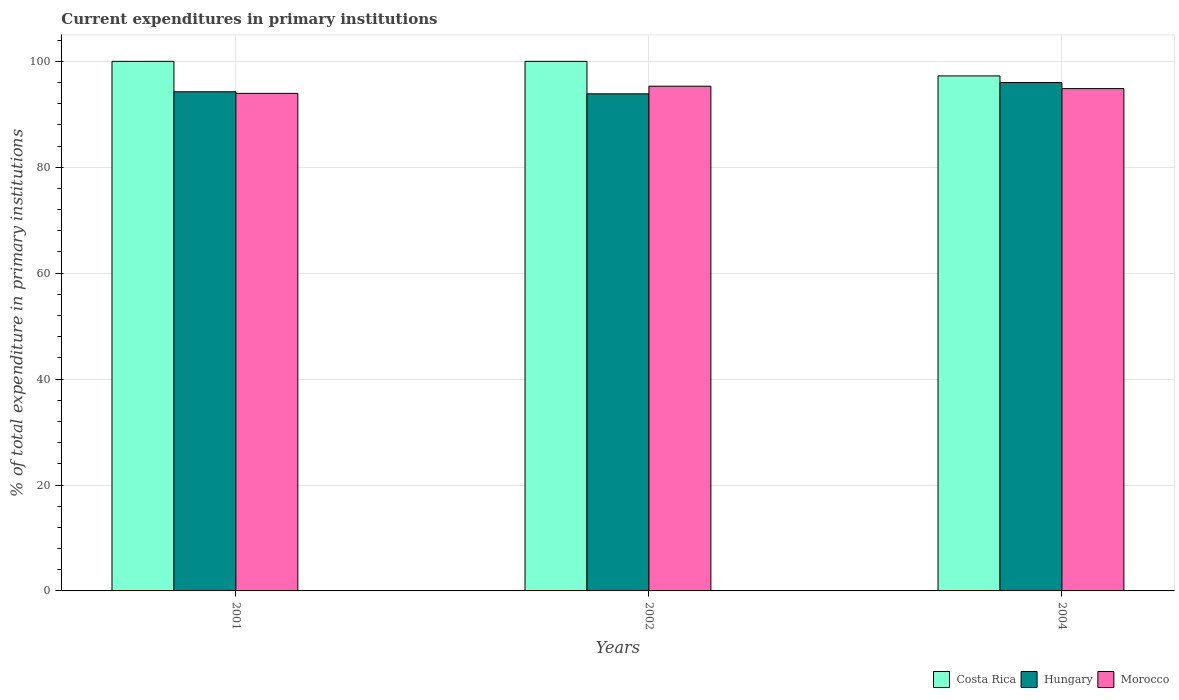How many bars are there on the 3rd tick from the left?
Your answer should be compact. 3. How many bars are there on the 1st tick from the right?
Offer a very short reply. 3. What is the label of the 2nd group of bars from the left?
Provide a short and direct response. 2002. Across all years, what is the maximum current expenditures in primary institutions in Morocco?
Ensure brevity in your answer.  95.31. Across all years, what is the minimum current expenditures in primary institutions in Hungary?
Keep it short and to the point. 93.87. In which year was the current expenditures in primary institutions in Morocco maximum?
Your response must be concise. 2002. What is the total current expenditures in primary institutions in Costa Rica in the graph?
Offer a very short reply. 297.25. What is the difference between the current expenditures in primary institutions in Morocco in 2001 and that in 2004?
Provide a short and direct response. -0.9. What is the difference between the current expenditures in primary institutions in Hungary in 2001 and the current expenditures in primary institutions in Costa Rica in 2004?
Your response must be concise. -2.99. What is the average current expenditures in primary institutions in Hungary per year?
Offer a terse response. 94.71. In the year 2001, what is the difference between the current expenditures in primary institutions in Morocco and current expenditures in primary institutions in Hungary?
Your answer should be very brief. -0.3. What is the ratio of the current expenditures in primary institutions in Morocco in 2002 to that in 2004?
Provide a short and direct response. 1. Is the current expenditures in primary institutions in Costa Rica in 2001 less than that in 2002?
Offer a terse response. No. What is the difference between the highest and the second highest current expenditures in primary institutions in Morocco?
Your response must be concise. 0.46. What is the difference between the highest and the lowest current expenditures in primary institutions in Morocco?
Your answer should be compact. 1.36. Is the sum of the current expenditures in primary institutions in Morocco in 2002 and 2004 greater than the maximum current expenditures in primary institutions in Costa Rica across all years?
Make the answer very short. Yes. What does the 2nd bar from the right in 2001 represents?
Your response must be concise. Hungary. Is it the case that in every year, the sum of the current expenditures in primary institutions in Costa Rica and current expenditures in primary institutions in Hungary is greater than the current expenditures in primary institutions in Morocco?
Offer a terse response. Yes. What is the difference between two consecutive major ticks on the Y-axis?
Keep it short and to the point. 20. Are the values on the major ticks of Y-axis written in scientific E-notation?
Provide a succinct answer. No. Where does the legend appear in the graph?
Your answer should be compact. Bottom right. How are the legend labels stacked?
Offer a terse response. Horizontal. What is the title of the graph?
Offer a very short reply. Current expenditures in primary institutions. Does "Belgium" appear as one of the legend labels in the graph?
Your answer should be compact. No. What is the label or title of the Y-axis?
Ensure brevity in your answer.  % of total expenditure in primary institutions. What is the % of total expenditure in primary institutions of Costa Rica in 2001?
Make the answer very short. 100. What is the % of total expenditure in primary institutions of Hungary in 2001?
Provide a succinct answer. 94.26. What is the % of total expenditure in primary institutions in Morocco in 2001?
Your answer should be very brief. 93.95. What is the % of total expenditure in primary institutions in Costa Rica in 2002?
Give a very brief answer. 100. What is the % of total expenditure in primary institutions of Hungary in 2002?
Your response must be concise. 93.87. What is the % of total expenditure in primary institutions of Morocco in 2002?
Your response must be concise. 95.31. What is the % of total expenditure in primary institutions of Costa Rica in 2004?
Provide a succinct answer. 97.25. What is the % of total expenditure in primary institutions of Hungary in 2004?
Offer a terse response. 96. What is the % of total expenditure in primary institutions of Morocco in 2004?
Your response must be concise. 94.85. Across all years, what is the maximum % of total expenditure in primary institutions in Hungary?
Keep it short and to the point. 96. Across all years, what is the maximum % of total expenditure in primary institutions in Morocco?
Give a very brief answer. 95.31. Across all years, what is the minimum % of total expenditure in primary institutions of Costa Rica?
Ensure brevity in your answer.  97.25. Across all years, what is the minimum % of total expenditure in primary institutions of Hungary?
Make the answer very short. 93.87. Across all years, what is the minimum % of total expenditure in primary institutions in Morocco?
Offer a very short reply. 93.95. What is the total % of total expenditure in primary institutions of Costa Rica in the graph?
Your answer should be compact. 297.25. What is the total % of total expenditure in primary institutions of Hungary in the graph?
Make the answer very short. 284.13. What is the total % of total expenditure in primary institutions of Morocco in the graph?
Offer a very short reply. 284.11. What is the difference between the % of total expenditure in primary institutions of Costa Rica in 2001 and that in 2002?
Keep it short and to the point. 0. What is the difference between the % of total expenditure in primary institutions of Hungary in 2001 and that in 2002?
Provide a succinct answer. 0.39. What is the difference between the % of total expenditure in primary institutions of Morocco in 2001 and that in 2002?
Your answer should be compact. -1.36. What is the difference between the % of total expenditure in primary institutions in Costa Rica in 2001 and that in 2004?
Offer a very short reply. 2.75. What is the difference between the % of total expenditure in primary institutions in Hungary in 2001 and that in 2004?
Provide a succinct answer. -1.74. What is the difference between the % of total expenditure in primary institutions of Morocco in 2001 and that in 2004?
Provide a succinct answer. -0.9. What is the difference between the % of total expenditure in primary institutions in Costa Rica in 2002 and that in 2004?
Your response must be concise. 2.75. What is the difference between the % of total expenditure in primary institutions of Hungary in 2002 and that in 2004?
Keep it short and to the point. -2.13. What is the difference between the % of total expenditure in primary institutions in Morocco in 2002 and that in 2004?
Offer a very short reply. 0.46. What is the difference between the % of total expenditure in primary institutions in Costa Rica in 2001 and the % of total expenditure in primary institutions in Hungary in 2002?
Give a very brief answer. 6.13. What is the difference between the % of total expenditure in primary institutions in Costa Rica in 2001 and the % of total expenditure in primary institutions in Morocco in 2002?
Offer a terse response. 4.69. What is the difference between the % of total expenditure in primary institutions of Hungary in 2001 and the % of total expenditure in primary institutions of Morocco in 2002?
Give a very brief answer. -1.05. What is the difference between the % of total expenditure in primary institutions of Costa Rica in 2001 and the % of total expenditure in primary institutions of Hungary in 2004?
Make the answer very short. 4. What is the difference between the % of total expenditure in primary institutions in Costa Rica in 2001 and the % of total expenditure in primary institutions in Morocco in 2004?
Your answer should be compact. 5.15. What is the difference between the % of total expenditure in primary institutions in Hungary in 2001 and the % of total expenditure in primary institutions in Morocco in 2004?
Provide a short and direct response. -0.59. What is the difference between the % of total expenditure in primary institutions of Costa Rica in 2002 and the % of total expenditure in primary institutions of Hungary in 2004?
Make the answer very short. 4. What is the difference between the % of total expenditure in primary institutions in Costa Rica in 2002 and the % of total expenditure in primary institutions in Morocco in 2004?
Ensure brevity in your answer.  5.15. What is the difference between the % of total expenditure in primary institutions of Hungary in 2002 and the % of total expenditure in primary institutions of Morocco in 2004?
Your answer should be compact. -0.98. What is the average % of total expenditure in primary institutions of Costa Rica per year?
Keep it short and to the point. 99.08. What is the average % of total expenditure in primary institutions in Hungary per year?
Provide a succinct answer. 94.71. What is the average % of total expenditure in primary institutions in Morocco per year?
Offer a very short reply. 94.7. In the year 2001, what is the difference between the % of total expenditure in primary institutions of Costa Rica and % of total expenditure in primary institutions of Hungary?
Your answer should be very brief. 5.74. In the year 2001, what is the difference between the % of total expenditure in primary institutions of Costa Rica and % of total expenditure in primary institutions of Morocco?
Provide a short and direct response. 6.05. In the year 2001, what is the difference between the % of total expenditure in primary institutions of Hungary and % of total expenditure in primary institutions of Morocco?
Give a very brief answer. 0.3. In the year 2002, what is the difference between the % of total expenditure in primary institutions of Costa Rica and % of total expenditure in primary institutions of Hungary?
Give a very brief answer. 6.13. In the year 2002, what is the difference between the % of total expenditure in primary institutions of Costa Rica and % of total expenditure in primary institutions of Morocco?
Your answer should be compact. 4.69. In the year 2002, what is the difference between the % of total expenditure in primary institutions in Hungary and % of total expenditure in primary institutions in Morocco?
Give a very brief answer. -1.44. In the year 2004, what is the difference between the % of total expenditure in primary institutions in Costa Rica and % of total expenditure in primary institutions in Hungary?
Your answer should be very brief. 1.25. In the year 2004, what is the difference between the % of total expenditure in primary institutions of Costa Rica and % of total expenditure in primary institutions of Morocco?
Provide a succinct answer. 2.4. In the year 2004, what is the difference between the % of total expenditure in primary institutions of Hungary and % of total expenditure in primary institutions of Morocco?
Keep it short and to the point. 1.15. What is the ratio of the % of total expenditure in primary institutions in Hungary in 2001 to that in 2002?
Offer a terse response. 1. What is the ratio of the % of total expenditure in primary institutions in Morocco in 2001 to that in 2002?
Your answer should be very brief. 0.99. What is the ratio of the % of total expenditure in primary institutions of Costa Rica in 2001 to that in 2004?
Your response must be concise. 1.03. What is the ratio of the % of total expenditure in primary institutions of Hungary in 2001 to that in 2004?
Offer a terse response. 0.98. What is the ratio of the % of total expenditure in primary institutions in Morocco in 2001 to that in 2004?
Your response must be concise. 0.99. What is the ratio of the % of total expenditure in primary institutions in Costa Rica in 2002 to that in 2004?
Provide a short and direct response. 1.03. What is the ratio of the % of total expenditure in primary institutions in Hungary in 2002 to that in 2004?
Give a very brief answer. 0.98. What is the ratio of the % of total expenditure in primary institutions of Morocco in 2002 to that in 2004?
Make the answer very short. 1. What is the difference between the highest and the second highest % of total expenditure in primary institutions of Hungary?
Make the answer very short. 1.74. What is the difference between the highest and the second highest % of total expenditure in primary institutions in Morocco?
Your answer should be very brief. 0.46. What is the difference between the highest and the lowest % of total expenditure in primary institutions in Costa Rica?
Your answer should be very brief. 2.75. What is the difference between the highest and the lowest % of total expenditure in primary institutions in Hungary?
Your response must be concise. 2.13. What is the difference between the highest and the lowest % of total expenditure in primary institutions in Morocco?
Ensure brevity in your answer.  1.36. 